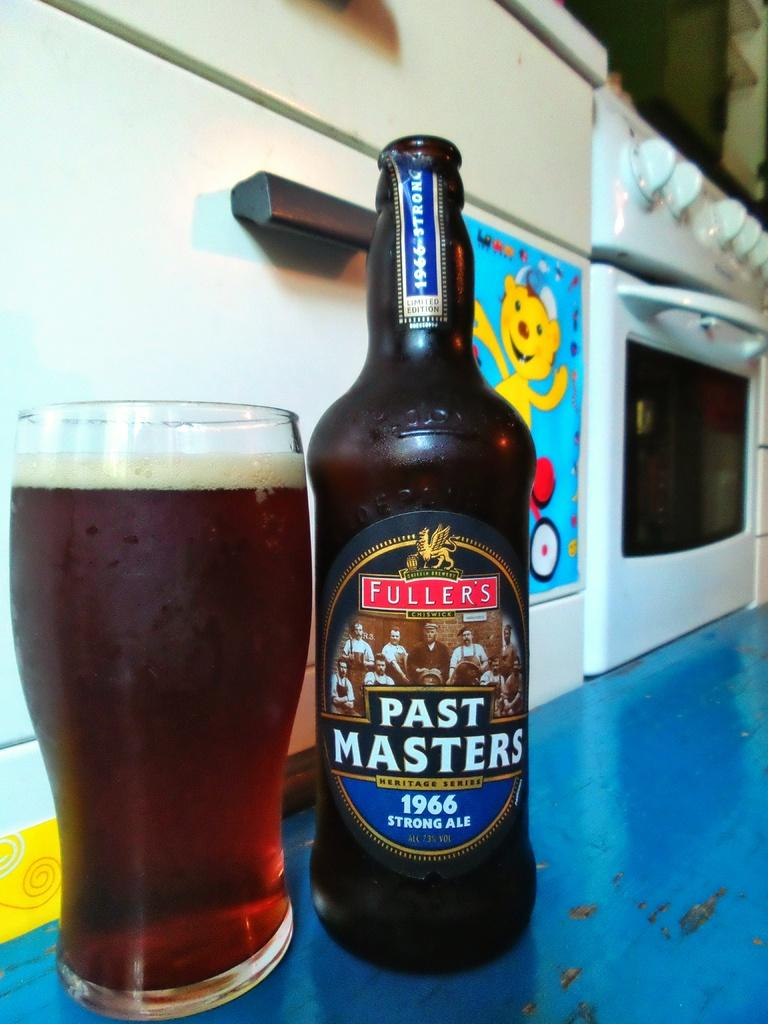<image>
Share a concise interpretation of the image provided. Beer fills a glass sitting next to a Past Masters bottle. 